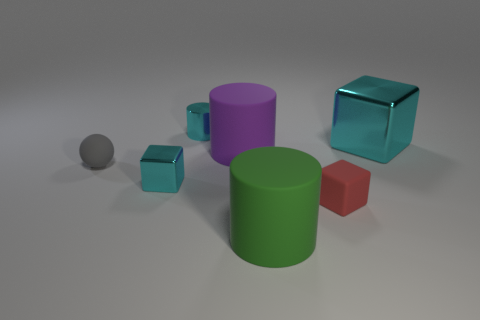Subtract all big rubber cylinders. How many cylinders are left? 1 Add 2 cyan metal spheres. How many objects exist? 9 Subtract all balls. How many objects are left? 6 Subtract all purple cylinders. Subtract all big metallic objects. How many objects are left? 5 Add 4 cyan shiny blocks. How many cyan shiny blocks are left? 6 Add 6 small yellow rubber spheres. How many small yellow rubber spheres exist? 6 Subtract 1 red blocks. How many objects are left? 6 